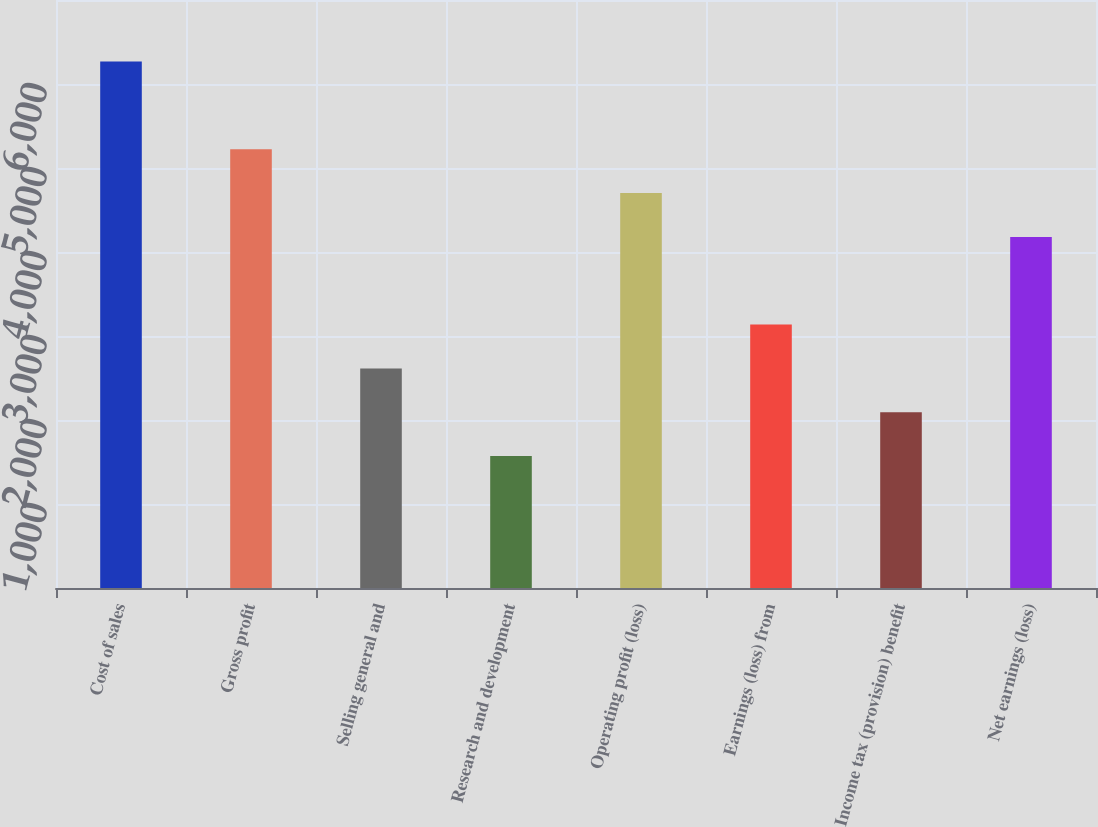<chart> <loc_0><loc_0><loc_500><loc_500><bar_chart><fcel>Cost of sales<fcel>Gross profit<fcel>Selling general and<fcel>Research and development<fcel>Operating profit (loss)<fcel>Earnings (loss) from<fcel>Income tax (provision) benefit<fcel>Net earnings (loss)<nl><fcel>6266.48<fcel>5223.02<fcel>2614.37<fcel>1570.91<fcel>4701.29<fcel>3136.1<fcel>2092.64<fcel>4179.56<nl></chart> 